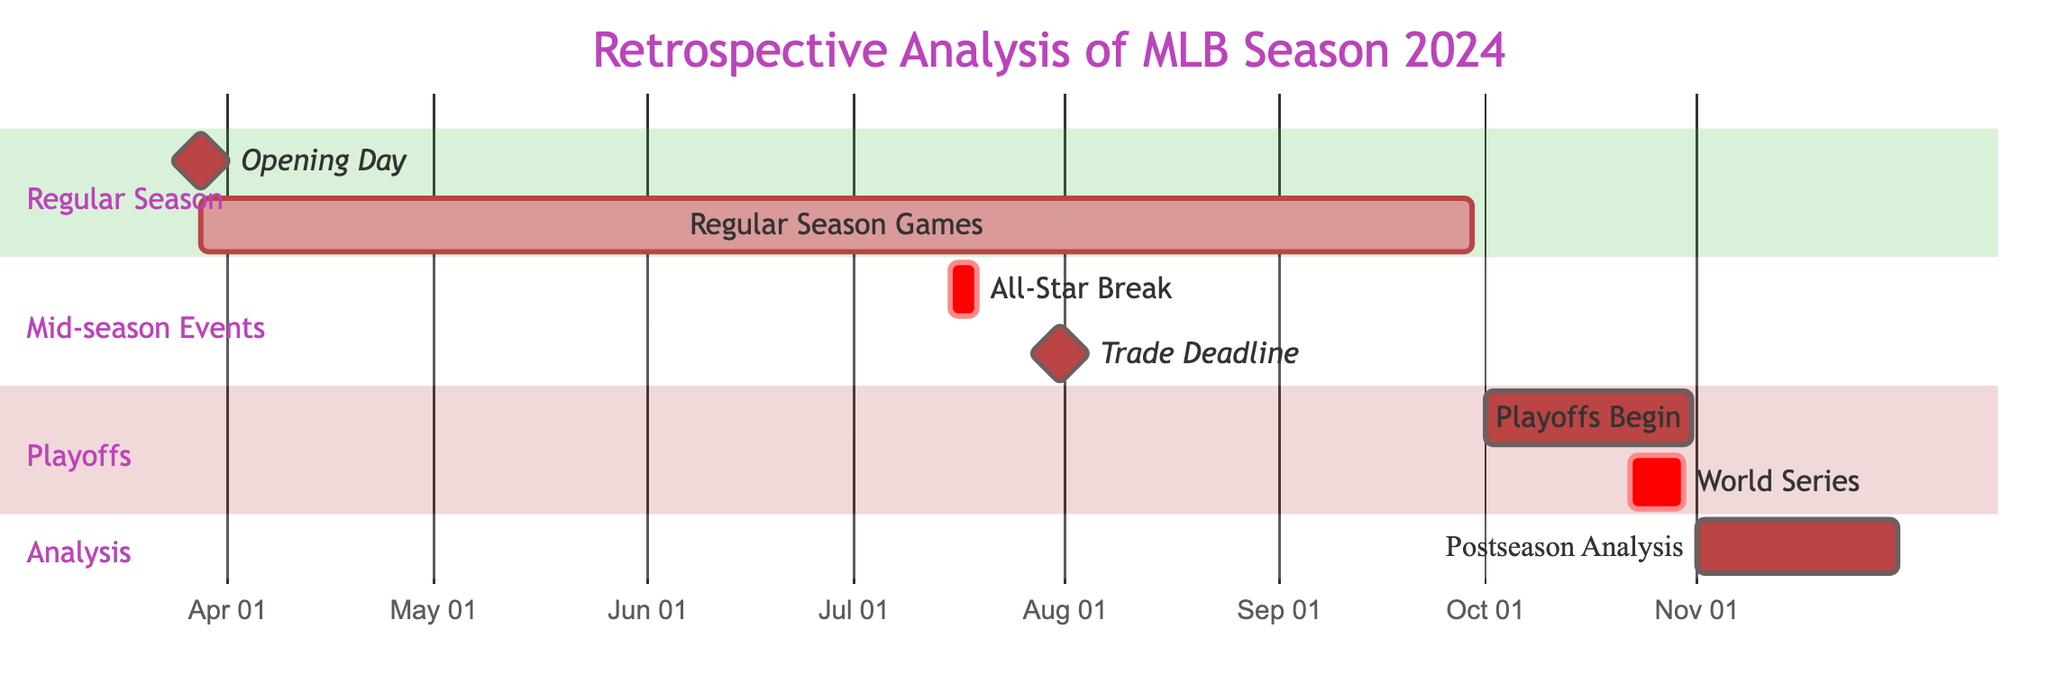What is the duration of the Regular Season Games? The Regular Season Games start on March 28, 2024, and end on September 29, 2024. Calculating the duration gives us 6 months (from March to September).
Answer: 6 months What date does the Trade Deadline occur? From the diagram, the Trade Deadline is represented as a milestone, which indicates it occurs on a specific date. The date given is July 31, 2024.
Answer: July 31, 2024 How many events are included in the Playoffs section? In the Playoffs section of the diagram, there are two events listed: Playoffs Begin and World Series. Therefore, when counting them, we find there are two events.
Answer: 2 When does Postseason Analysis start? The Postseason Analysis task starts on November 1, 2024. This is identified from the start date specified in the corresponding section of the Gantt Chart.
Answer: November 1, 2024 What event occurs immediately after the All-Star Break? The All-Star Break lasts from July 15 to July 18, 2024. Immediately after this event, the next notable event is the Trade Deadline, which occurs on July 31, 2024.
Answer: Trade Deadline How many days does the World Series last? The World Series starts on October 22, 2024, and ends on October 30, 2024. The duration can be calculated by counting the days between these two dates, which totals 9 days.
Answer: 9 days What is the last event in the Gantt chart? The last event listed is Postseason Analysis, which begins on November 1, 2024, and runs through to the end of November. This answers what the final event in the Gantt Chart is.
Answer: Postseason Analysis What is the time span from Opening Day to the end of Regular Season Games? Opening Day starts on March 28, 2024, and the Regular Season Games conclude on September 29, 2024. To find the span, we calculate the number of days between these two dates, which is 184 days.
Answer: 184 days 